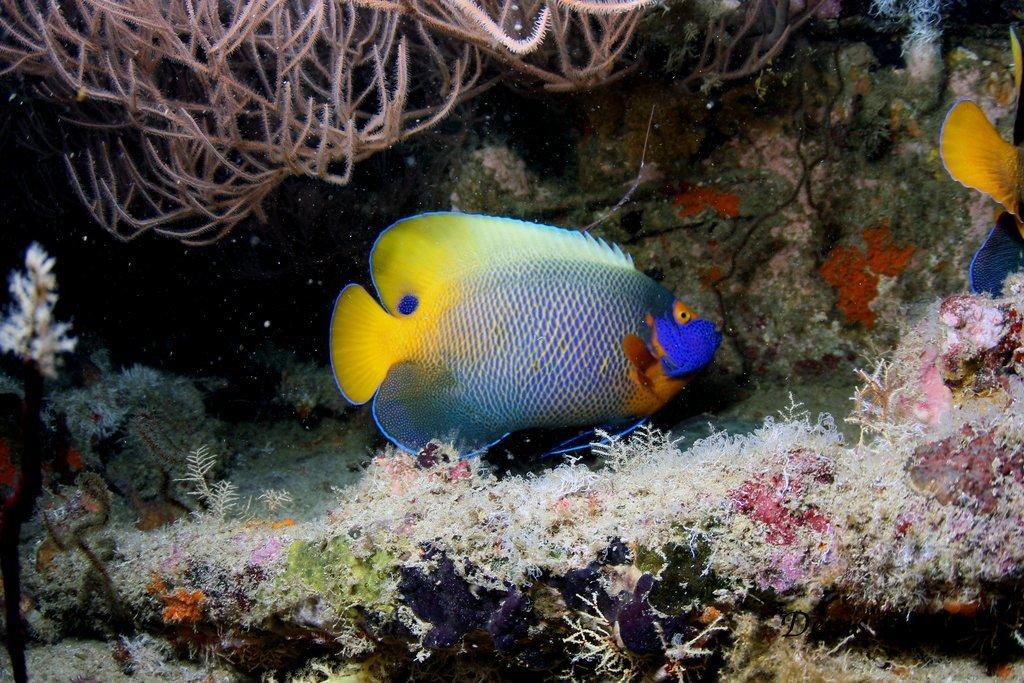What type of animals can be seen in the image? There are fishes in the image. What other elements can be seen in the image besides the fishes? There are water plants in the image. What type of structure can be seen in the image? There is no structure present in the image; it features fishes and water plants. Are there any horses visible in the image? There are no horses present in the image. 